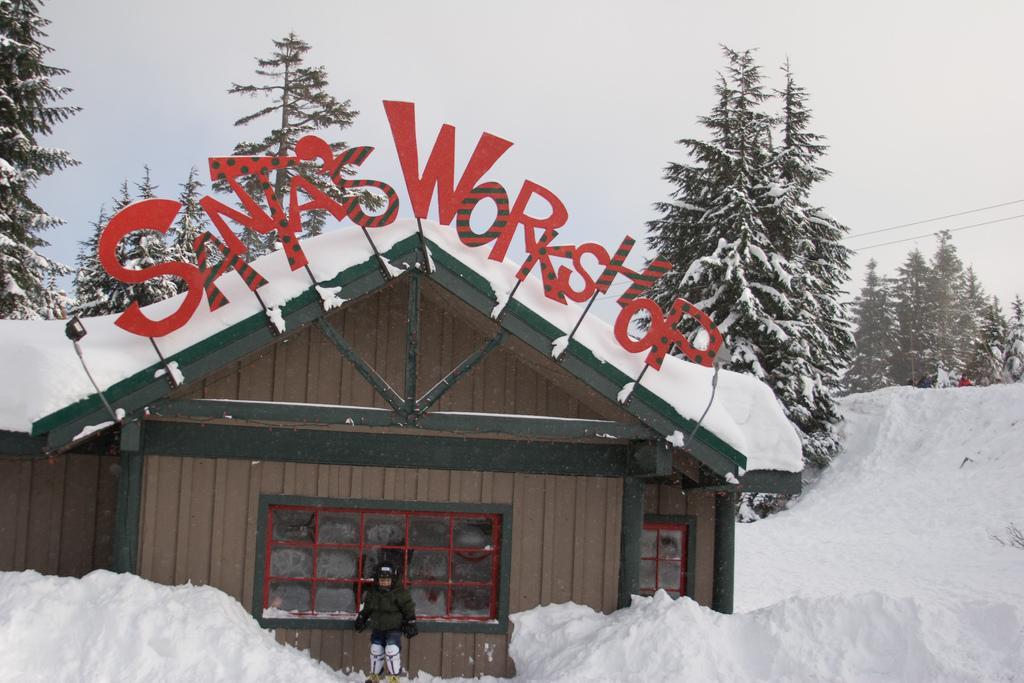In one or two sentences, can you explain what this image depicts? In this image there is the sky, there are wires truncated towards the right of the image, there are trees, there is ice, there are persons, there is a house, there is a light, there is a text on the house, there is a tree truncated towards the left of the image, there are trees truncated towards the right of the image. 